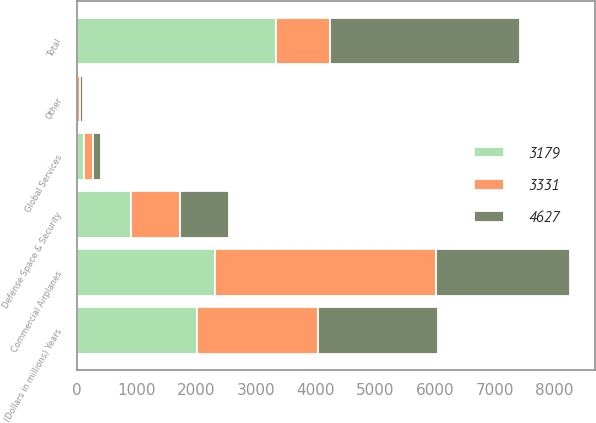<chart> <loc_0><loc_0><loc_500><loc_500><stacked_bar_chart><ecel><fcel>(Dollars in millions) Years<fcel>Commercial Airplanes<fcel>Defense Space & Security<fcel>Global Services<fcel>Other<fcel>Total<nl><fcel>4627<fcel>2017<fcel>2247<fcel>834<fcel>140<fcel>42<fcel>3179<nl><fcel>3331<fcel>2016<fcel>3706<fcel>815<fcel>153<fcel>47<fcel>902<nl><fcel>3179<fcel>2015<fcel>2311<fcel>902<fcel>113<fcel>5<fcel>3331<nl></chart> 